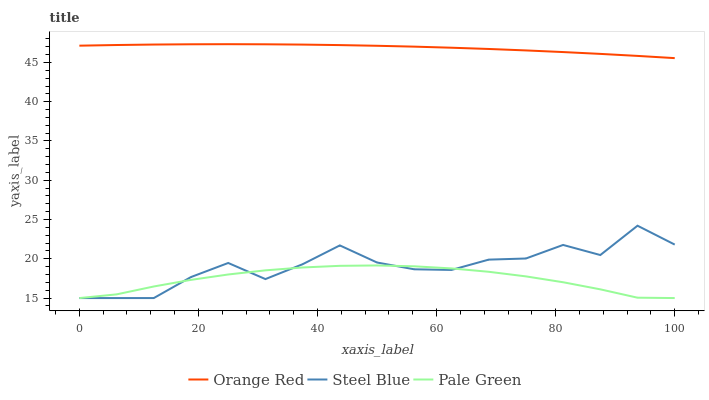Does Steel Blue have the minimum area under the curve?
Answer yes or no. No. Does Steel Blue have the maximum area under the curve?
Answer yes or no. No. Is Steel Blue the smoothest?
Answer yes or no. No. Is Orange Red the roughest?
Answer yes or no. No. Does Orange Red have the lowest value?
Answer yes or no. No. Does Steel Blue have the highest value?
Answer yes or no. No. Is Steel Blue less than Orange Red?
Answer yes or no. Yes. Is Orange Red greater than Pale Green?
Answer yes or no. Yes. Does Steel Blue intersect Orange Red?
Answer yes or no. No. 